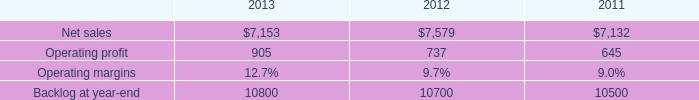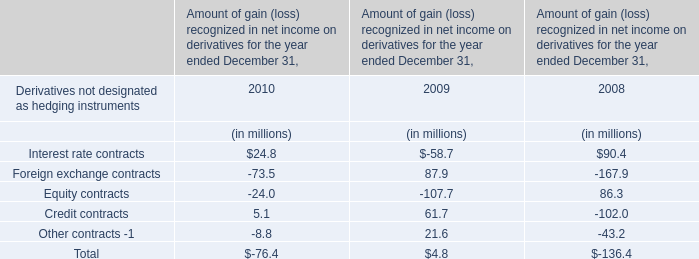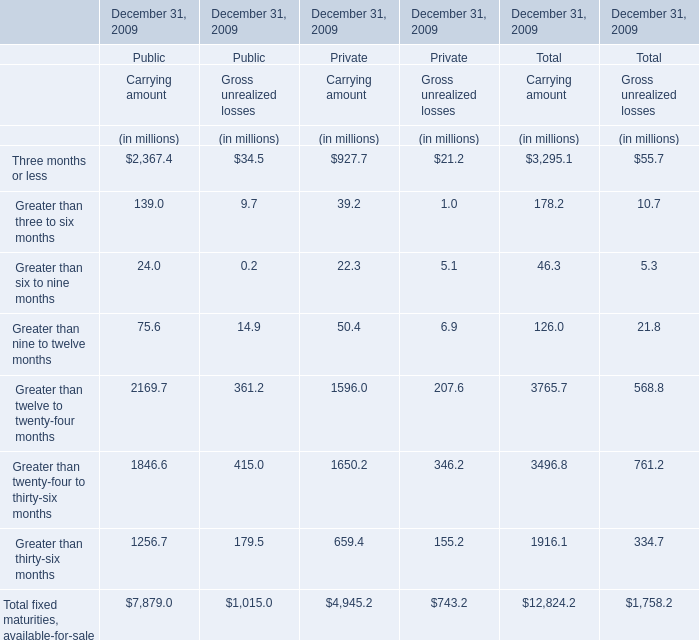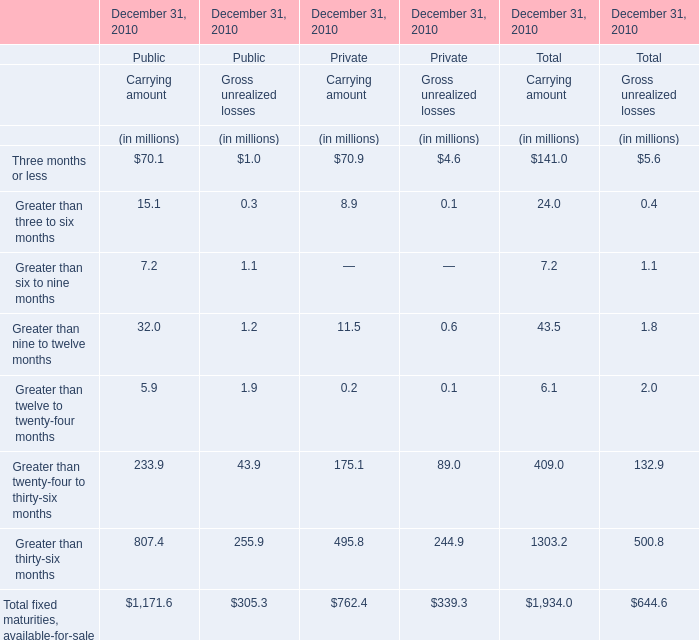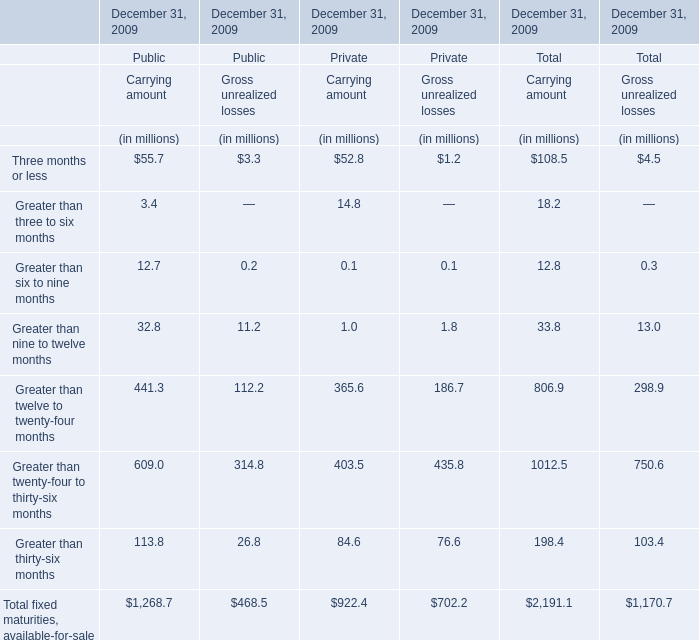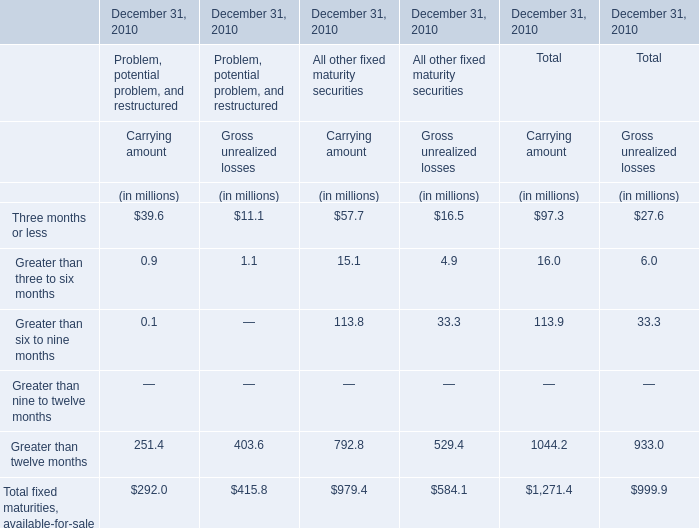What's the 20% of total elements for Carrying amount of Total in 2009? (in million) 
Computations: (2191.1 * 0.2)
Answer: 438.22. 